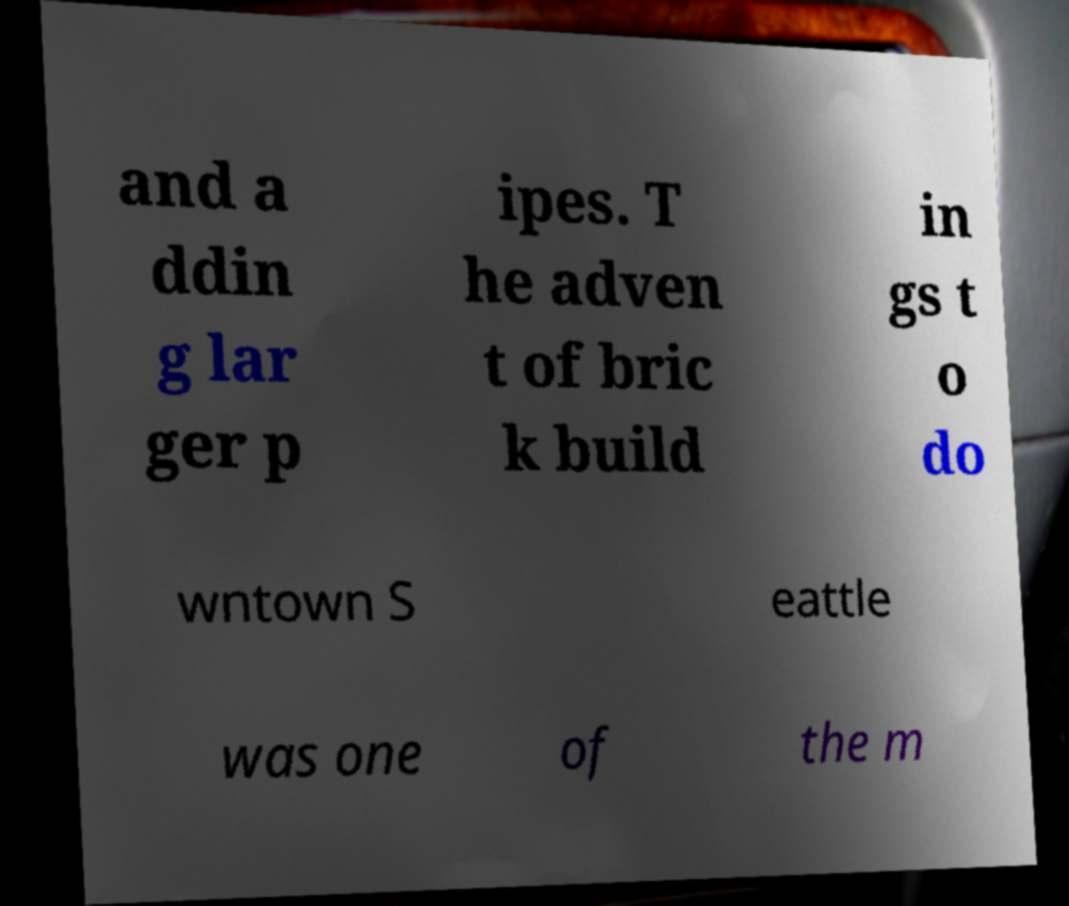Please identify and transcribe the text found in this image. and a ddin g lar ger p ipes. T he adven t of bric k build in gs t o do wntown S eattle was one of the m 